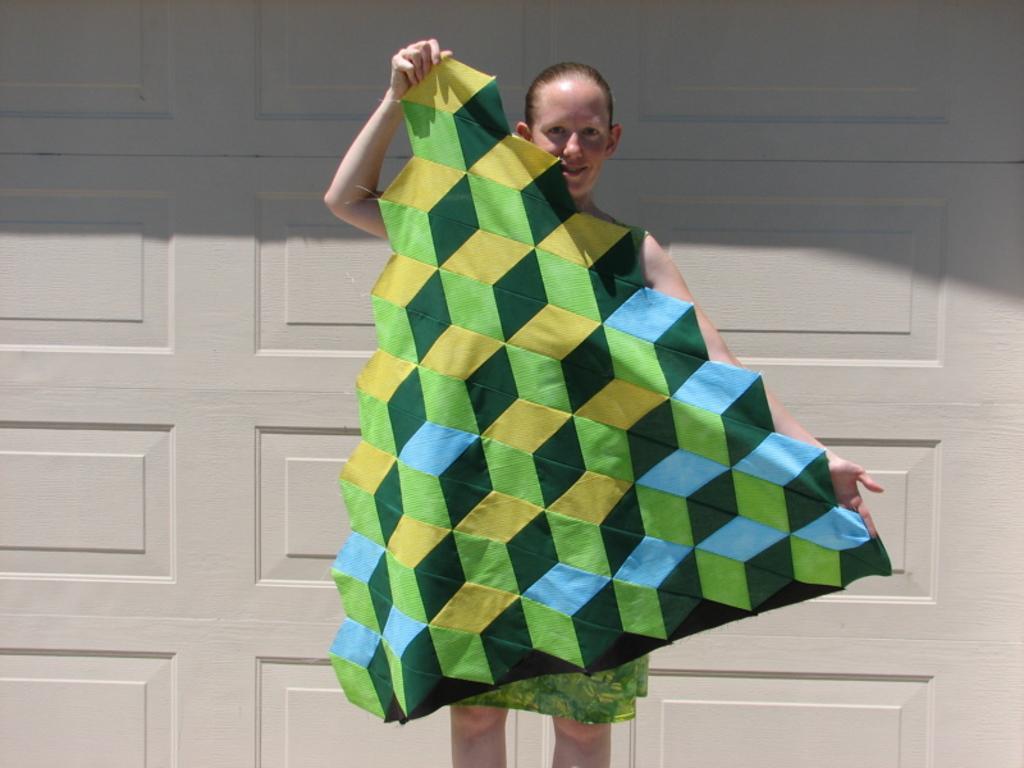Could you give a brief overview of what you see in this image? In this image, in the middle, we can see a woman holding a cloth in her two hands. In the background, we can see a white color wall. 